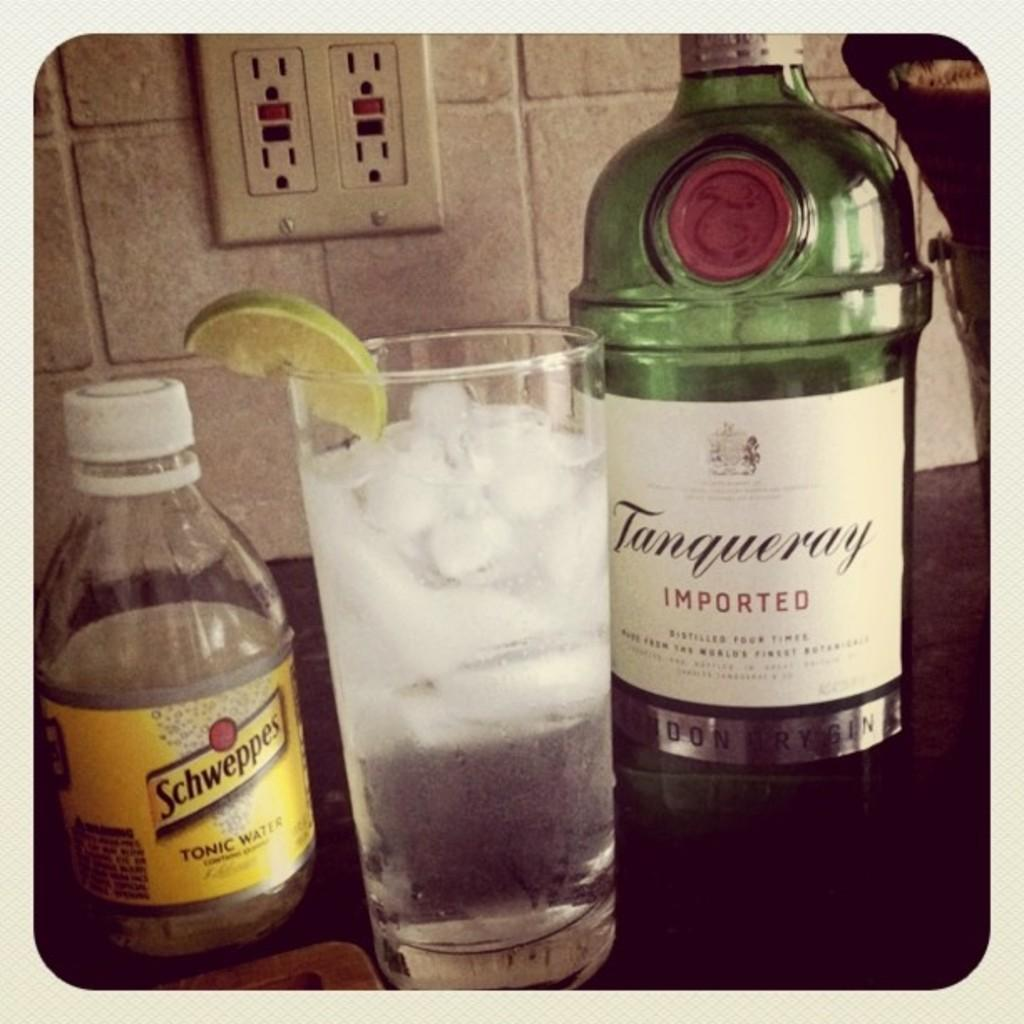<image>
Offer a succinct explanation of the picture presented. A bottle of water ice in between a bottle of Imported Tanqueray and Schweppes Tonic Water. 